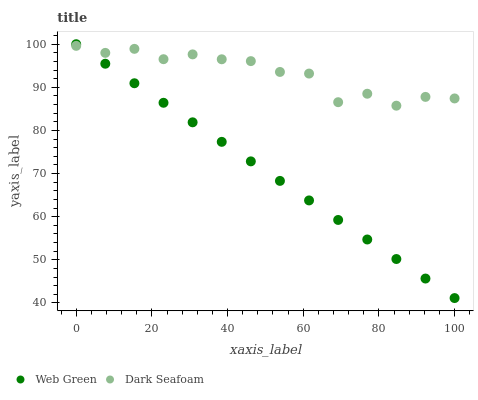Does Web Green have the minimum area under the curve?
Answer yes or no. Yes. Does Dark Seafoam have the maximum area under the curve?
Answer yes or no. Yes. Does Web Green have the maximum area under the curve?
Answer yes or no. No. Is Web Green the smoothest?
Answer yes or no. Yes. Is Dark Seafoam the roughest?
Answer yes or no. Yes. Is Web Green the roughest?
Answer yes or no. No. Does Web Green have the lowest value?
Answer yes or no. Yes. Does Web Green have the highest value?
Answer yes or no. Yes. Does Dark Seafoam intersect Web Green?
Answer yes or no. Yes. Is Dark Seafoam less than Web Green?
Answer yes or no. No. Is Dark Seafoam greater than Web Green?
Answer yes or no. No. 